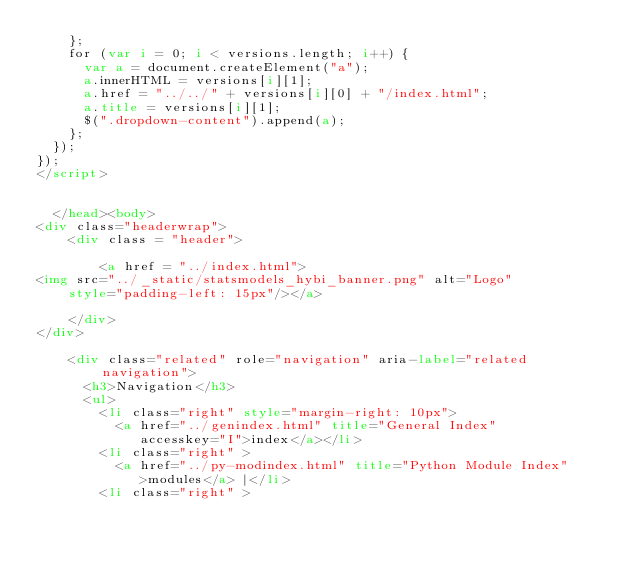Convert code to text. <code><loc_0><loc_0><loc_500><loc_500><_HTML_>    };
    for (var i = 0; i < versions.length; i++) {
      var a = document.createElement("a");
      a.innerHTML = versions[i][1];
      a.href = "../../" + versions[i][0] + "/index.html";
      a.title = versions[i][1];
      $(".dropdown-content").append(a);
    };
  });
});
</script>


  </head><body>
<div class="headerwrap">
    <div class = "header">
        
        <a href = "../index.html">
<img src="../_static/statsmodels_hybi_banner.png" alt="Logo"
    style="padding-left: 15px"/></a>
        
    </div>
</div>

    <div class="related" role="navigation" aria-label="related navigation">
      <h3>Navigation</h3>
      <ul>
        <li class="right" style="margin-right: 10px">
          <a href="../genindex.html" title="General Index"
             accesskey="I">index</a></li>
        <li class="right" >
          <a href="../py-modindex.html" title="Python Module Index"
             >modules</a> |</li>
        <li class="right" ></code> 